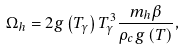<formula> <loc_0><loc_0><loc_500><loc_500>\Omega _ { h } = 2 g \left ( T _ { \gamma } \right ) T _ { \gamma } ^ { 3 } \frac { m _ { h } \beta } { \rho _ { c } g \left ( T \right ) } ,</formula> 